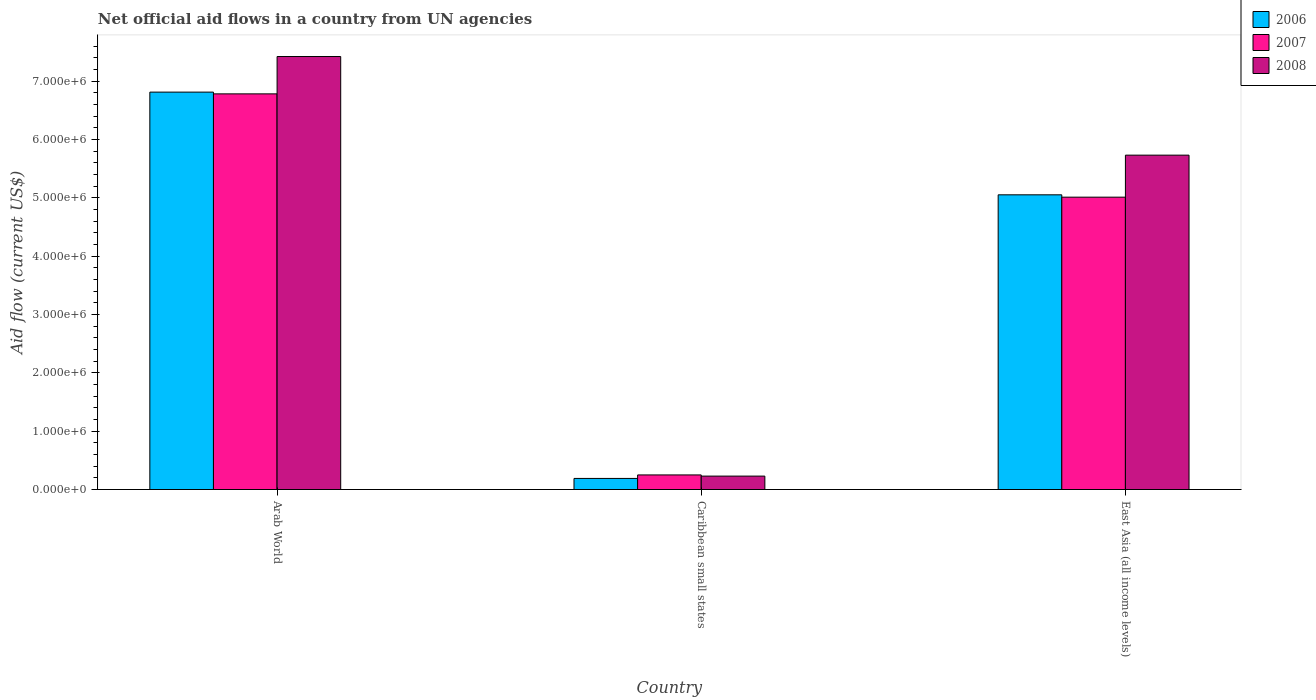How many groups of bars are there?
Your answer should be compact. 3. How many bars are there on the 2nd tick from the left?
Offer a very short reply. 3. What is the label of the 1st group of bars from the left?
Your answer should be compact. Arab World. Across all countries, what is the maximum net official aid flow in 2007?
Ensure brevity in your answer.  6.78e+06. Across all countries, what is the minimum net official aid flow in 2007?
Make the answer very short. 2.50e+05. In which country was the net official aid flow in 2007 maximum?
Your answer should be compact. Arab World. In which country was the net official aid flow in 2008 minimum?
Ensure brevity in your answer.  Caribbean small states. What is the total net official aid flow in 2007 in the graph?
Keep it short and to the point. 1.20e+07. What is the difference between the net official aid flow in 2008 in Caribbean small states and that in East Asia (all income levels)?
Keep it short and to the point. -5.50e+06. What is the difference between the net official aid flow in 2008 in East Asia (all income levels) and the net official aid flow in 2006 in Arab World?
Your response must be concise. -1.08e+06. What is the average net official aid flow in 2006 per country?
Give a very brief answer. 4.02e+06. What is the ratio of the net official aid flow in 2006 in Arab World to that in Caribbean small states?
Your response must be concise. 35.84. Is the net official aid flow in 2007 in Caribbean small states less than that in East Asia (all income levels)?
Ensure brevity in your answer.  Yes. Is the difference between the net official aid flow in 2008 in Arab World and East Asia (all income levels) greater than the difference between the net official aid flow in 2006 in Arab World and East Asia (all income levels)?
Provide a short and direct response. No. What is the difference between the highest and the second highest net official aid flow in 2008?
Your response must be concise. 7.19e+06. What is the difference between the highest and the lowest net official aid flow in 2007?
Make the answer very short. 6.53e+06. In how many countries, is the net official aid flow in 2008 greater than the average net official aid flow in 2008 taken over all countries?
Your response must be concise. 2. What does the 3rd bar from the right in East Asia (all income levels) represents?
Your answer should be very brief. 2006. Is it the case that in every country, the sum of the net official aid flow in 2006 and net official aid flow in 2007 is greater than the net official aid flow in 2008?
Offer a very short reply. Yes. How many countries are there in the graph?
Provide a succinct answer. 3. What is the difference between two consecutive major ticks on the Y-axis?
Your answer should be compact. 1.00e+06. Does the graph contain grids?
Provide a short and direct response. No. What is the title of the graph?
Ensure brevity in your answer.  Net official aid flows in a country from UN agencies. Does "1960" appear as one of the legend labels in the graph?
Give a very brief answer. No. What is the label or title of the Y-axis?
Make the answer very short. Aid flow (current US$). What is the Aid flow (current US$) of 2006 in Arab World?
Provide a succinct answer. 6.81e+06. What is the Aid flow (current US$) in 2007 in Arab World?
Your answer should be compact. 6.78e+06. What is the Aid flow (current US$) in 2008 in Arab World?
Provide a short and direct response. 7.42e+06. What is the Aid flow (current US$) in 2006 in Caribbean small states?
Your answer should be very brief. 1.90e+05. What is the Aid flow (current US$) of 2006 in East Asia (all income levels)?
Provide a succinct answer. 5.05e+06. What is the Aid flow (current US$) of 2007 in East Asia (all income levels)?
Provide a succinct answer. 5.01e+06. What is the Aid flow (current US$) of 2008 in East Asia (all income levels)?
Your answer should be compact. 5.73e+06. Across all countries, what is the maximum Aid flow (current US$) of 2006?
Your response must be concise. 6.81e+06. Across all countries, what is the maximum Aid flow (current US$) of 2007?
Your answer should be compact. 6.78e+06. Across all countries, what is the maximum Aid flow (current US$) in 2008?
Provide a succinct answer. 7.42e+06. What is the total Aid flow (current US$) of 2006 in the graph?
Your answer should be very brief. 1.20e+07. What is the total Aid flow (current US$) of 2007 in the graph?
Your answer should be very brief. 1.20e+07. What is the total Aid flow (current US$) of 2008 in the graph?
Keep it short and to the point. 1.34e+07. What is the difference between the Aid flow (current US$) of 2006 in Arab World and that in Caribbean small states?
Make the answer very short. 6.62e+06. What is the difference between the Aid flow (current US$) in 2007 in Arab World and that in Caribbean small states?
Offer a terse response. 6.53e+06. What is the difference between the Aid flow (current US$) in 2008 in Arab World and that in Caribbean small states?
Ensure brevity in your answer.  7.19e+06. What is the difference between the Aid flow (current US$) in 2006 in Arab World and that in East Asia (all income levels)?
Your answer should be very brief. 1.76e+06. What is the difference between the Aid flow (current US$) of 2007 in Arab World and that in East Asia (all income levels)?
Give a very brief answer. 1.77e+06. What is the difference between the Aid flow (current US$) in 2008 in Arab World and that in East Asia (all income levels)?
Provide a short and direct response. 1.69e+06. What is the difference between the Aid flow (current US$) in 2006 in Caribbean small states and that in East Asia (all income levels)?
Make the answer very short. -4.86e+06. What is the difference between the Aid flow (current US$) in 2007 in Caribbean small states and that in East Asia (all income levels)?
Your answer should be compact. -4.76e+06. What is the difference between the Aid flow (current US$) of 2008 in Caribbean small states and that in East Asia (all income levels)?
Provide a short and direct response. -5.50e+06. What is the difference between the Aid flow (current US$) in 2006 in Arab World and the Aid flow (current US$) in 2007 in Caribbean small states?
Provide a succinct answer. 6.56e+06. What is the difference between the Aid flow (current US$) of 2006 in Arab World and the Aid flow (current US$) of 2008 in Caribbean small states?
Your response must be concise. 6.58e+06. What is the difference between the Aid flow (current US$) of 2007 in Arab World and the Aid flow (current US$) of 2008 in Caribbean small states?
Provide a short and direct response. 6.55e+06. What is the difference between the Aid flow (current US$) of 2006 in Arab World and the Aid flow (current US$) of 2007 in East Asia (all income levels)?
Offer a terse response. 1.80e+06. What is the difference between the Aid flow (current US$) of 2006 in Arab World and the Aid flow (current US$) of 2008 in East Asia (all income levels)?
Offer a very short reply. 1.08e+06. What is the difference between the Aid flow (current US$) in 2007 in Arab World and the Aid flow (current US$) in 2008 in East Asia (all income levels)?
Offer a very short reply. 1.05e+06. What is the difference between the Aid flow (current US$) in 2006 in Caribbean small states and the Aid flow (current US$) in 2007 in East Asia (all income levels)?
Provide a short and direct response. -4.82e+06. What is the difference between the Aid flow (current US$) in 2006 in Caribbean small states and the Aid flow (current US$) in 2008 in East Asia (all income levels)?
Ensure brevity in your answer.  -5.54e+06. What is the difference between the Aid flow (current US$) in 2007 in Caribbean small states and the Aid flow (current US$) in 2008 in East Asia (all income levels)?
Ensure brevity in your answer.  -5.48e+06. What is the average Aid flow (current US$) of 2006 per country?
Your answer should be very brief. 4.02e+06. What is the average Aid flow (current US$) in 2007 per country?
Provide a succinct answer. 4.01e+06. What is the average Aid flow (current US$) of 2008 per country?
Make the answer very short. 4.46e+06. What is the difference between the Aid flow (current US$) in 2006 and Aid flow (current US$) in 2008 in Arab World?
Give a very brief answer. -6.10e+05. What is the difference between the Aid flow (current US$) of 2007 and Aid flow (current US$) of 2008 in Arab World?
Ensure brevity in your answer.  -6.40e+05. What is the difference between the Aid flow (current US$) in 2006 and Aid flow (current US$) in 2008 in Caribbean small states?
Give a very brief answer. -4.00e+04. What is the difference between the Aid flow (current US$) in 2007 and Aid flow (current US$) in 2008 in Caribbean small states?
Offer a very short reply. 2.00e+04. What is the difference between the Aid flow (current US$) of 2006 and Aid flow (current US$) of 2007 in East Asia (all income levels)?
Make the answer very short. 4.00e+04. What is the difference between the Aid flow (current US$) in 2006 and Aid flow (current US$) in 2008 in East Asia (all income levels)?
Provide a short and direct response. -6.80e+05. What is the difference between the Aid flow (current US$) in 2007 and Aid flow (current US$) in 2008 in East Asia (all income levels)?
Ensure brevity in your answer.  -7.20e+05. What is the ratio of the Aid flow (current US$) in 2006 in Arab World to that in Caribbean small states?
Give a very brief answer. 35.84. What is the ratio of the Aid flow (current US$) in 2007 in Arab World to that in Caribbean small states?
Your response must be concise. 27.12. What is the ratio of the Aid flow (current US$) in 2008 in Arab World to that in Caribbean small states?
Ensure brevity in your answer.  32.26. What is the ratio of the Aid flow (current US$) in 2006 in Arab World to that in East Asia (all income levels)?
Keep it short and to the point. 1.35. What is the ratio of the Aid flow (current US$) of 2007 in Arab World to that in East Asia (all income levels)?
Keep it short and to the point. 1.35. What is the ratio of the Aid flow (current US$) of 2008 in Arab World to that in East Asia (all income levels)?
Ensure brevity in your answer.  1.29. What is the ratio of the Aid flow (current US$) of 2006 in Caribbean small states to that in East Asia (all income levels)?
Provide a succinct answer. 0.04. What is the ratio of the Aid flow (current US$) in 2007 in Caribbean small states to that in East Asia (all income levels)?
Provide a succinct answer. 0.05. What is the ratio of the Aid flow (current US$) in 2008 in Caribbean small states to that in East Asia (all income levels)?
Give a very brief answer. 0.04. What is the difference between the highest and the second highest Aid flow (current US$) of 2006?
Offer a very short reply. 1.76e+06. What is the difference between the highest and the second highest Aid flow (current US$) in 2007?
Your response must be concise. 1.77e+06. What is the difference between the highest and the second highest Aid flow (current US$) of 2008?
Provide a short and direct response. 1.69e+06. What is the difference between the highest and the lowest Aid flow (current US$) in 2006?
Ensure brevity in your answer.  6.62e+06. What is the difference between the highest and the lowest Aid flow (current US$) of 2007?
Your answer should be compact. 6.53e+06. What is the difference between the highest and the lowest Aid flow (current US$) of 2008?
Offer a terse response. 7.19e+06. 